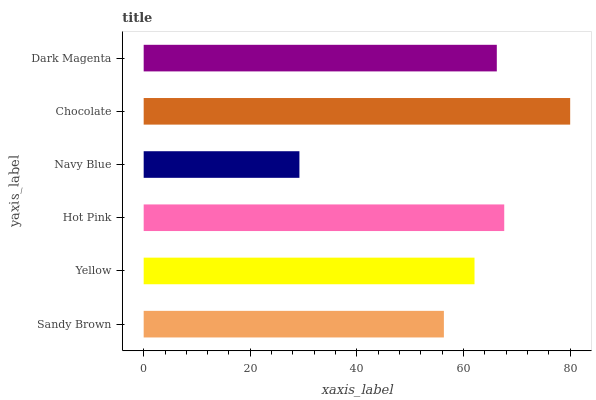Is Navy Blue the minimum?
Answer yes or no. Yes. Is Chocolate the maximum?
Answer yes or no. Yes. Is Yellow the minimum?
Answer yes or no. No. Is Yellow the maximum?
Answer yes or no. No. Is Yellow greater than Sandy Brown?
Answer yes or no. Yes. Is Sandy Brown less than Yellow?
Answer yes or no. Yes. Is Sandy Brown greater than Yellow?
Answer yes or no. No. Is Yellow less than Sandy Brown?
Answer yes or no. No. Is Dark Magenta the high median?
Answer yes or no. Yes. Is Yellow the low median?
Answer yes or no. Yes. Is Navy Blue the high median?
Answer yes or no. No. Is Chocolate the low median?
Answer yes or no. No. 